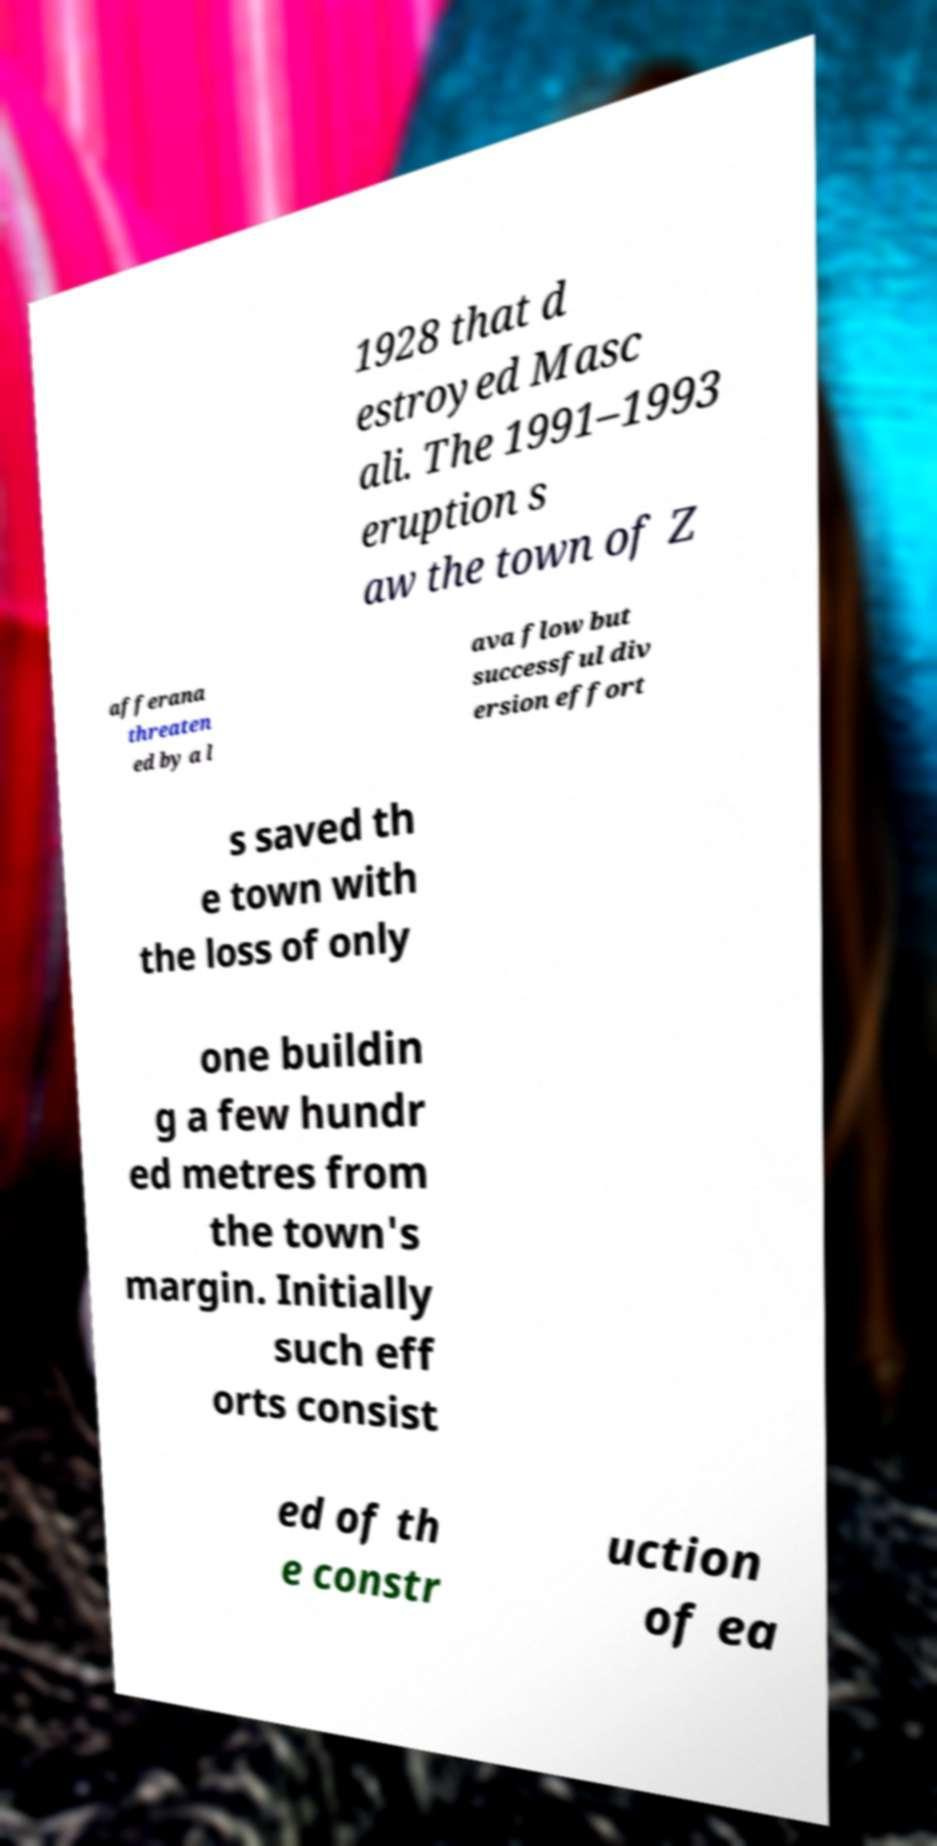Could you assist in decoding the text presented in this image and type it out clearly? 1928 that d estroyed Masc ali. The 1991–1993 eruption s aw the town of Z afferana threaten ed by a l ava flow but successful div ersion effort s saved th e town with the loss of only one buildin g a few hundr ed metres from the town's margin. Initially such eff orts consist ed of th e constr uction of ea 